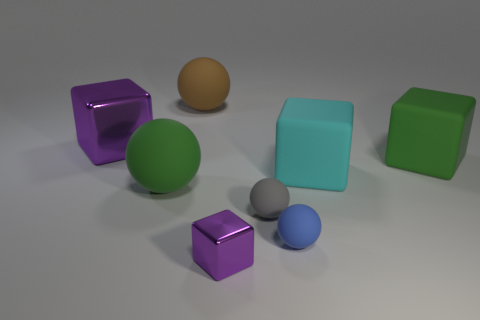Subtract all yellow balls. How many purple blocks are left? 2 Subtract all small blocks. How many blocks are left? 3 Add 2 brown matte things. How many objects exist? 10 Subtract all brown spheres. How many spheres are left? 3 Subtract all yellow balls. Subtract all yellow cylinders. How many balls are left? 4 Subtract all cyan rubber cubes. Subtract all big matte balls. How many objects are left? 5 Add 4 large cyan rubber blocks. How many large cyan rubber blocks are left? 5 Add 8 big cyan cubes. How many big cyan cubes exist? 9 Subtract 1 purple cubes. How many objects are left? 7 